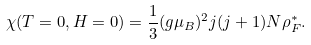Convert formula to latex. <formula><loc_0><loc_0><loc_500><loc_500>\chi ( T = 0 , H = 0 ) = \frac { 1 } { 3 } ( g \mu _ { B } ) ^ { 2 } j ( j + 1 ) N \rho _ { F } ^ { * } .</formula> 